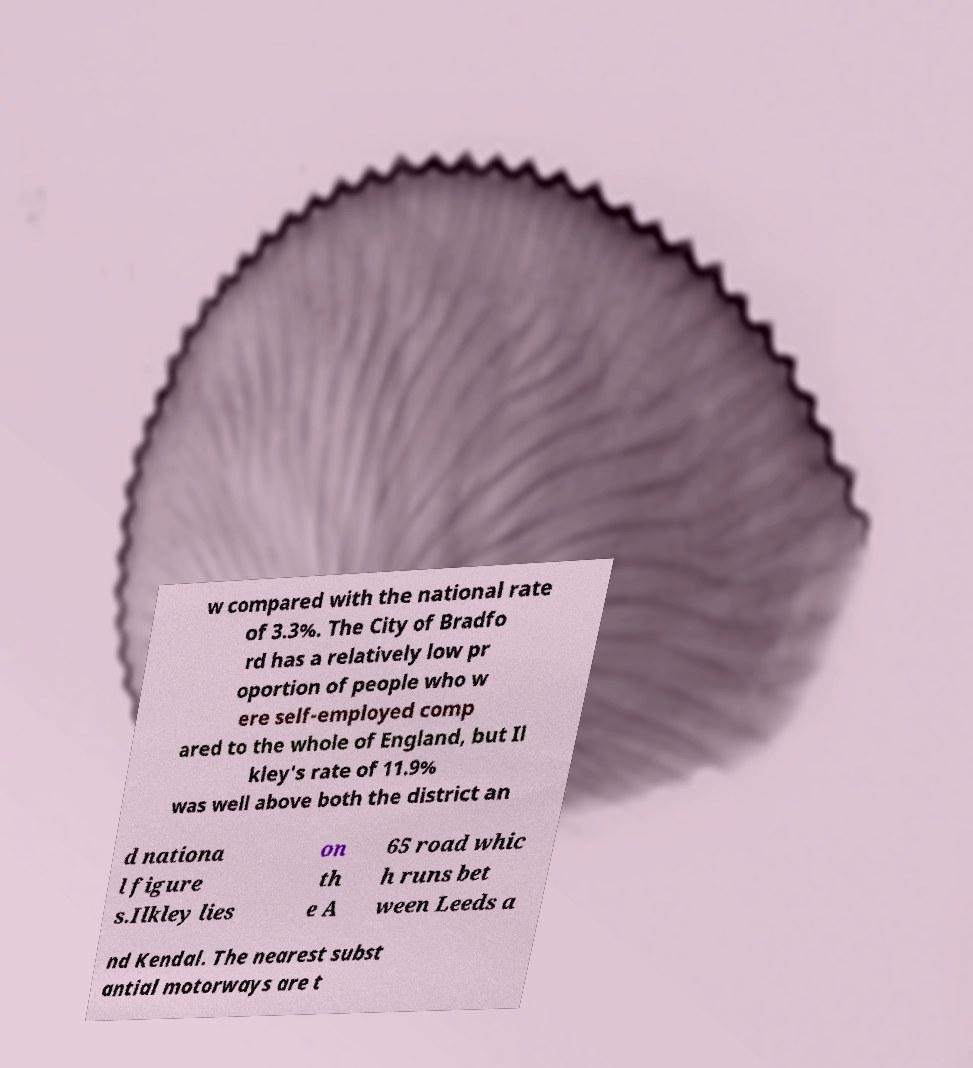Can you read and provide the text displayed in the image?This photo seems to have some interesting text. Can you extract and type it out for me? w compared with the national rate of 3.3%. The City of Bradfo rd has a relatively low pr oportion of people who w ere self-employed comp ared to the whole of England, but Il kley's rate of 11.9% was well above both the district an d nationa l figure s.Ilkley lies on th e A 65 road whic h runs bet ween Leeds a nd Kendal. The nearest subst antial motorways are t 